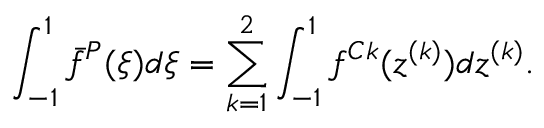<formula> <loc_0><loc_0><loc_500><loc_500>\int _ { - 1 } ^ { 1 } \bar { f } ^ { P } ( \xi ) d \xi = \sum _ { k = 1 } ^ { 2 } \int _ { - 1 } ^ { 1 } f ^ { C k } ( z ^ { ( k ) } ) d z ^ { ( k ) } .</formula> 